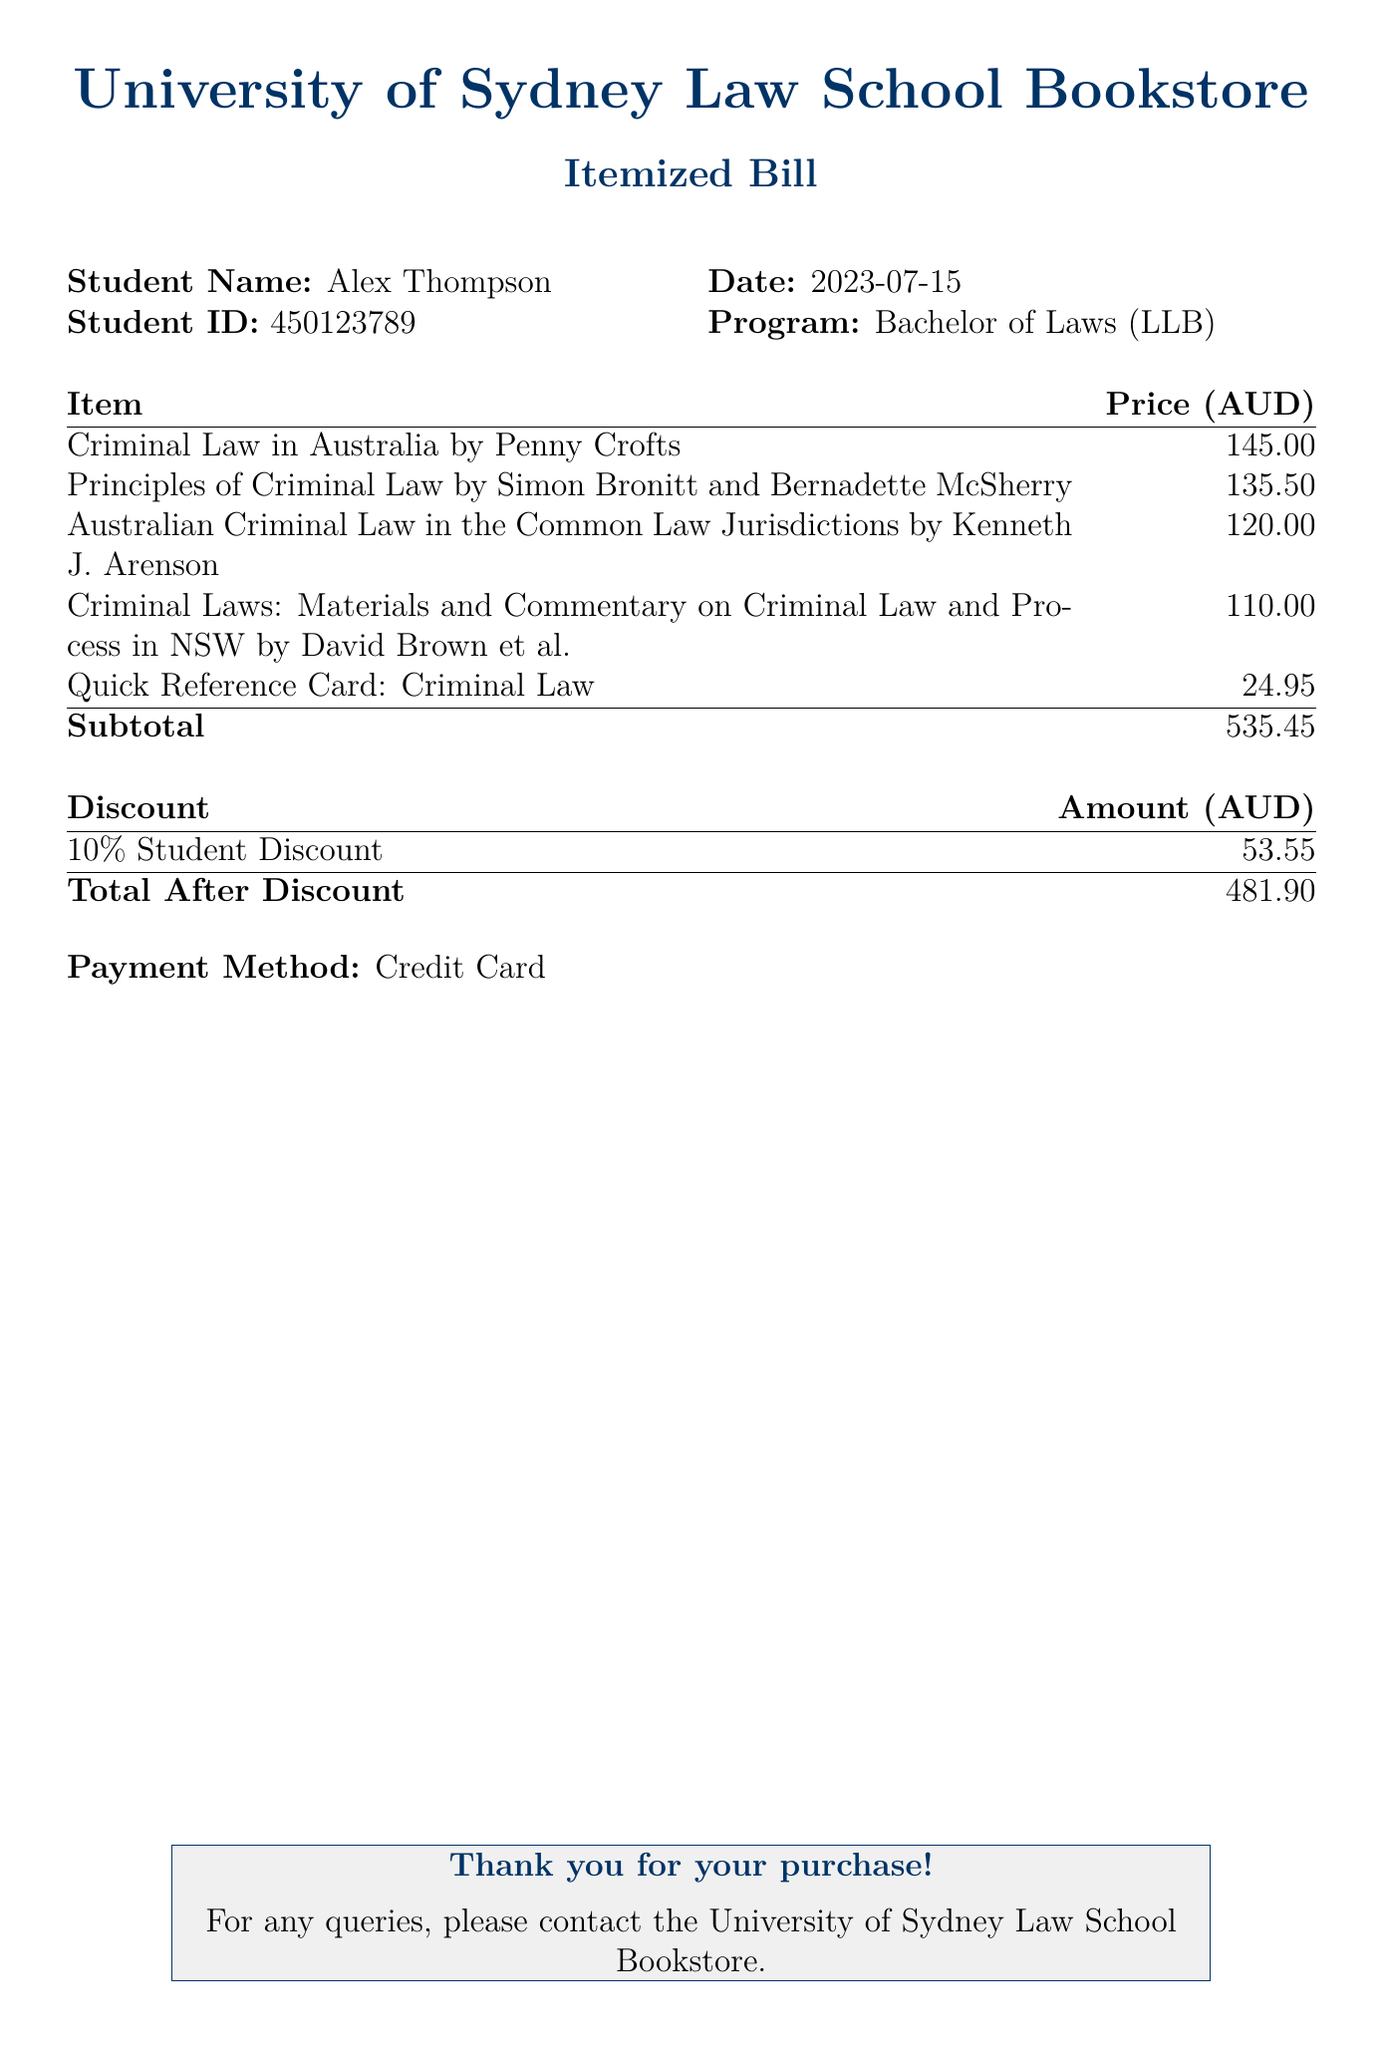What is the total price before discounts? The total price before discounts is listed as the subtotal in the document, which adds up the prices of all items.
Answer: 535.45 What discount percentage was applied? The discount is provided in the document as a percentage, specifically listed next to the discount amount.
Answer: 10% What is the name of the first textbook listed? The first textbook listed in the itemized bill appears at the top of the item list.
Answer: Criminal Law in Australia by Penny Crofts What is the total amount after discounts? The total amount after discounts is specifically stated at the bottom of the document.
Answer: 481.90 What payment method was used for the purchase? The payment method is mentioned clearly at the end of the bill.
Answer: Credit Card How much is the Quick Reference Card: Criminal Law? The price of the Quick Reference Card is mentioned next to its title in the item list.
Answer: 24.95 Who is the student named on the bill? The student's name is stated at the top of the document.
Answer: Alex Thompson What is the total discount amount applied? The total discount amount can be found in the discount section of the document.
Answer: 53.55 What is the publication year of the textbooks? The publication year is not specifically mentioned in the document, as the focus is on titles and prices.
Answer: Not specified 